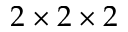<formula> <loc_0><loc_0><loc_500><loc_500>2 \times 2 \times 2</formula> 